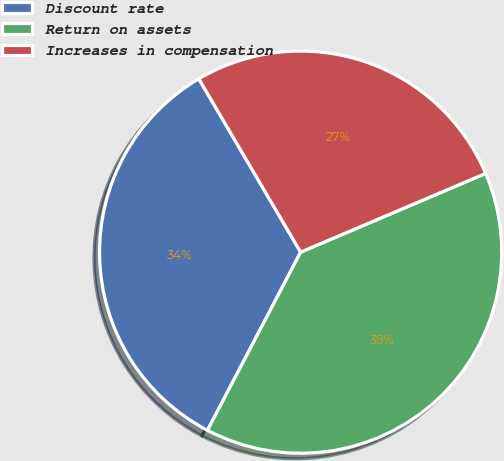Convert chart. <chart><loc_0><loc_0><loc_500><loc_500><pie_chart><fcel>Discount rate<fcel>Return on assets<fcel>Increases in compensation<nl><fcel>33.88%<fcel>39.07%<fcel>27.05%<nl></chart> 